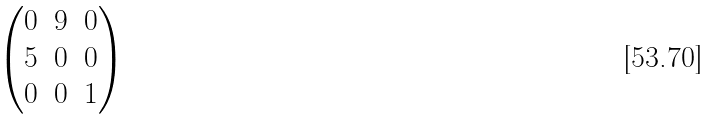<formula> <loc_0><loc_0><loc_500><loc_500>\begin{pmatrix} 0 & 9 & 0 \\ 5 & 0 & 0 \\ 0 & 0 & 1 \end{pmatrix}</formula> 